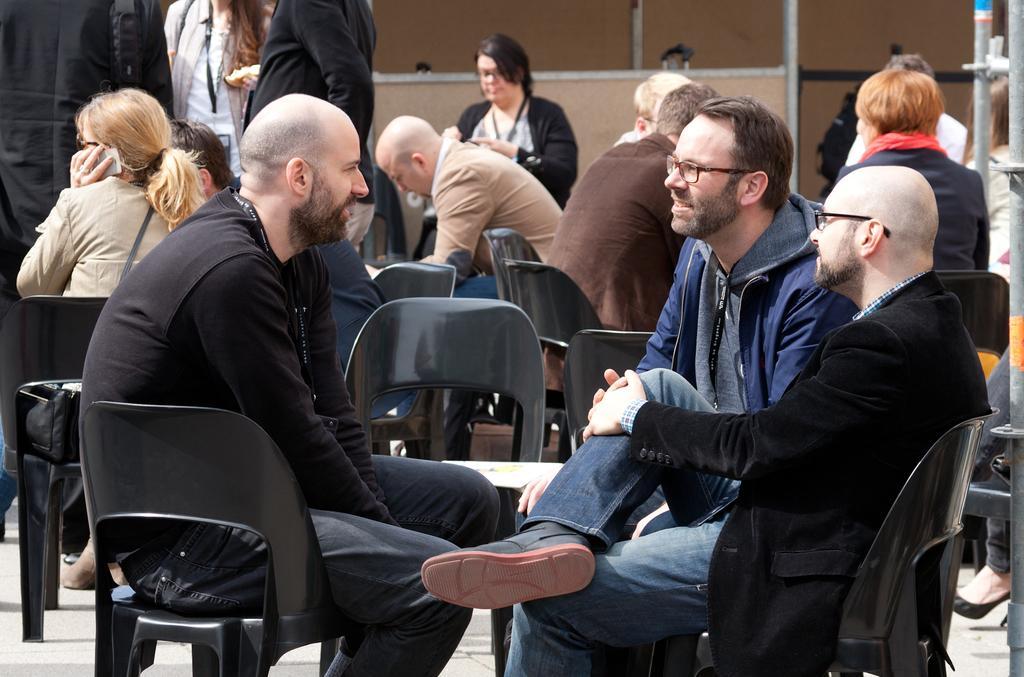Describe this image in one or two sentences. In this picture, There are some chairs which are in black color and there are some people siting on the chairs and they are discussing and in the background there is a yellow color wall. 